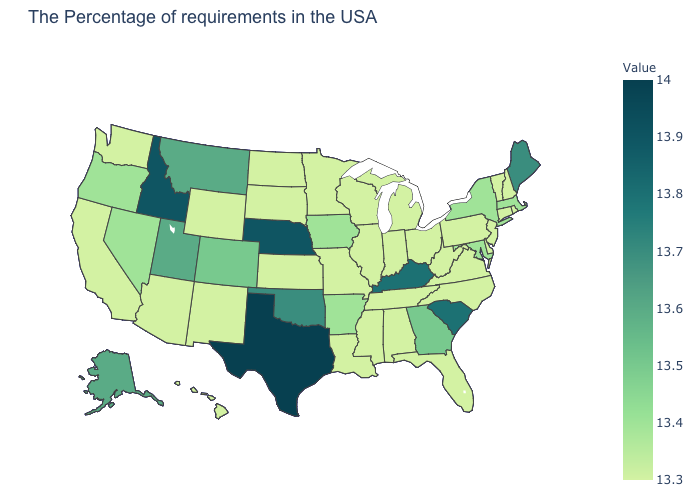Does Arizona have the highest value in the West?
Concise answer only. No. Is the legend a continuous bar?
Be succinct. Yes. Among the states that border Wyoming , does Montana have the lowest value?
Concise answer only. No. Which states have the lowest value in the USA?
Answer briefly. Rhode Island, New Hampshire, Vermont, Connecticut, New Jersey, Delaware, Pennsylvania, Virginia, North Carolina, West Virginia, Ohio, Florida, Michigan, Indiana, Alabama, Tennessee, Wisconsin, Illinois, Mississippi, Louisiana, Missouri, Minnesota, Kansas, South Dakota, North Dakota, Wyoming, New Mexico, Arizona, California, Washington, Hawaii. Does the map have missing data?
Write a very short answer. No. Which states have the highest value in the USA?
Keep it brief. Texas. 